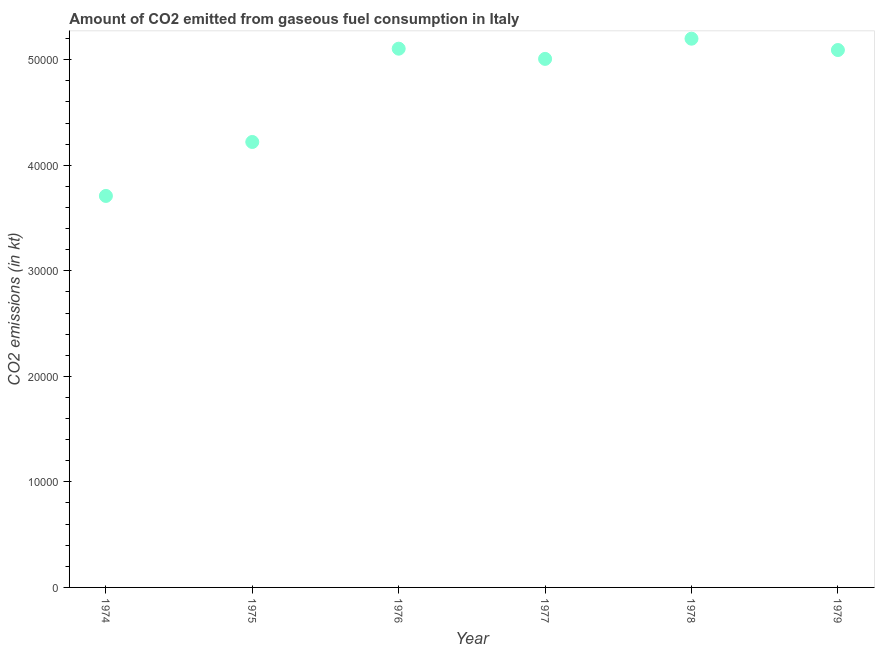What is the co2 emissions from gaseous fuel consumption in 1976?
Provide a succinct answer. 5.10e+04. Across all years, what is the maximum co2 emissions from gaseous fuel consumption?
Your response must be concise. 5.20e+04. Across all years, what is the minimum co2 emissions from gaseous fuel consumption?
Ensure brevity in your answer.  3.71e+04. In which year was the co2 emissions from gaseous fuel consumption maximum?
Give a very brief answer. 1978. In which year was the co2 emissions from gaseous fuel consumption minimum?
Keep it short and to the point. 1974. What is the sum of the co2 emissions from gaseous fuel consumption?
Provide a short and direct response. 2.83e+05. What is the difference between the co2 emissions from gaseous fuel consumption in 1976 and 1978?
Offer a very short reply. -946.09. What is the average co2 emissions from gaseous fuel consumption per year?
Provide a short and direct response. 4.72e+04. What is the median co2 emissions from gaseous fuel consumption?
Offer a terse response. 5.05e+04. What is the ratio of the co2 emissions from gaseous fuel consumption in 1976 to that in 1978?
Your response must be concise. 0.98. Is the co2 emissions from gaseous fuel consumption in 1976 less than that in 1977?
Offer a very short reply. No. Is the difference between the co2 emissions from gaseous fuel consumption in 1975 and 1978 greater than the difference between any two years?
Provide a short and direct response. No. What is the difference between the highest and the second highest co2 emissions from gaseous fuel consumption?
Offer a terse response. 946.09. What is the difference between the highest and the lowest co2 emissions from gaseous fuel consumption?
Your answer should be compact. 1.49e+04. How many dotlines are there?
Your answer should be very brief. 1. Are the values on the major ticks of Y-axis written in scientific E-notation?
Give a very brief answer. No. What is the title of the graph?
Your answer should be compact. Amount of CO2 emitted from gaseous fuel consumption in Italy. What is the label or title of the Y-axis?
Keep it short and to the point. CO2 emissions (in kt). What is the CO2 emissions (in kt) in 1974?
Make the answer very short. 3.71e+04. What is the CO2 emissions (in kt) in 1975?
Provide a succinct answer. 4.22e+04. What is the CO2 emissions (in kt) in 1976?
Ensure brevity in your answer.  5.10e+04. What is the CO2 emissions (in kt) in 1977?
Your response must be concise. 5.01e+04. What is the CO2 emissions (in kt) in 1978?
Provide a short and direct response. 5.20e+04. What is the CO2 emissions (in kt) in 1979?
Your answer should be very brief. 5.09e+04. What is the difference between the CO2 emissions (in kt) in 1974 and 1975?
Your response must be concise. -5111.8. What is the difference between the CO2 emissions (in kt) in 1974 and 1976?
Ensure brevity in your answer.  -1.40e+04. What is the difference between the CO2 emissions (in kt) in 1974 and 1977?
Provide a short and direct response. -1.30e+04. What is the difference between the CO2 emissions (in kt) in 1974 and 1978?
Keep it short and to the point. -1.49e+04. What is the difference between the CO2 emissions (in kt) in 1974 and 1979?
Your answer should be compact. -1.38e+04. What is the difference between the CO2 emissions (in kt) in 1975 and 1976?
Give a very brief answer. -8841.14. What is the difference between the CO2 emissions (in kt) in 1975 and 1977?
Offer a very short reply. -7873.05. What is the difference between the CO2 emissions (in kt) in 1975 and 1978?
Provide a short and direct response. -9787.22. What is the difference between the CO2 emissions (in kt) in 1975 and 1979?
Provide a short and direct response. -8712.79. What is the difference between the CO2 emissions (in kt) in 1976 and 1977?
Offer a very short reply. 968.09. What is the difference between the CO2 emissions (in kt) in 1976 and 1978?
Provide a short and direct response. -946.09. What is the difference between the CO2 emissions (in kt) in 1976 and 1979?
Your answer should be very brief. 128.34. What is the difference between the CO2 emissions (in kt) in 1977 and 1978?
Make the answer very short. -1914.17. What is the difference between the CO2 emissions (in kt) in 1977 and 1979?
Your answer should be compact. -839.74. What is the difference between the CO2 emissions (in kt) in 1978 and 1979?
Keep it short and to the point. 1074.43. What is the ratio of the CO2 emissions (in kt) in 1974 to that in 1975?
Offer a very short reply. 0.88. What is the ratio of the CO2 emissions (in kt) in 1974 to that in 1976?
Offer a terse response. 0.73. What is the ratio of the CO2 emissions (in kt) in 1974 to that in 1977?
Your answer should be very brief. 0.74. What is the ratio of the CO2 emissions (in kt) in 1974 to that in 1978?
Keep it short and to the point. 0.71. What is the ratio of the CO2 emissions (in kt) in 1974 to that in 1979?
Provide a short and direct response. 0.73. What is the ratio of the CO2 emissions (in kt) in 1975 to that in 1976?
Offer a terse response. 0.83. What is the ratio of the CO2 emissions (in kt) in 1975 to that in 1977?
Give a very brief answer. 0.84. What is the ratio of the CO2 emissions (in kt) in 1975 to that in 1978?
Give a very brief answer. 0.81. What is the ratio of the CO2 emissions (in kt) in 1975 to that in 1979?
Give a very brief answer. 0.83. What is the ratio of the CO2 emissions (in kt) in 1976 to that in 1978?
Keep it short and to the point. 0.98. What is the ratio of the CO2 emissions (in kt) in 1977 to that in 1978?
Your answer should be very brief. 0.96. 